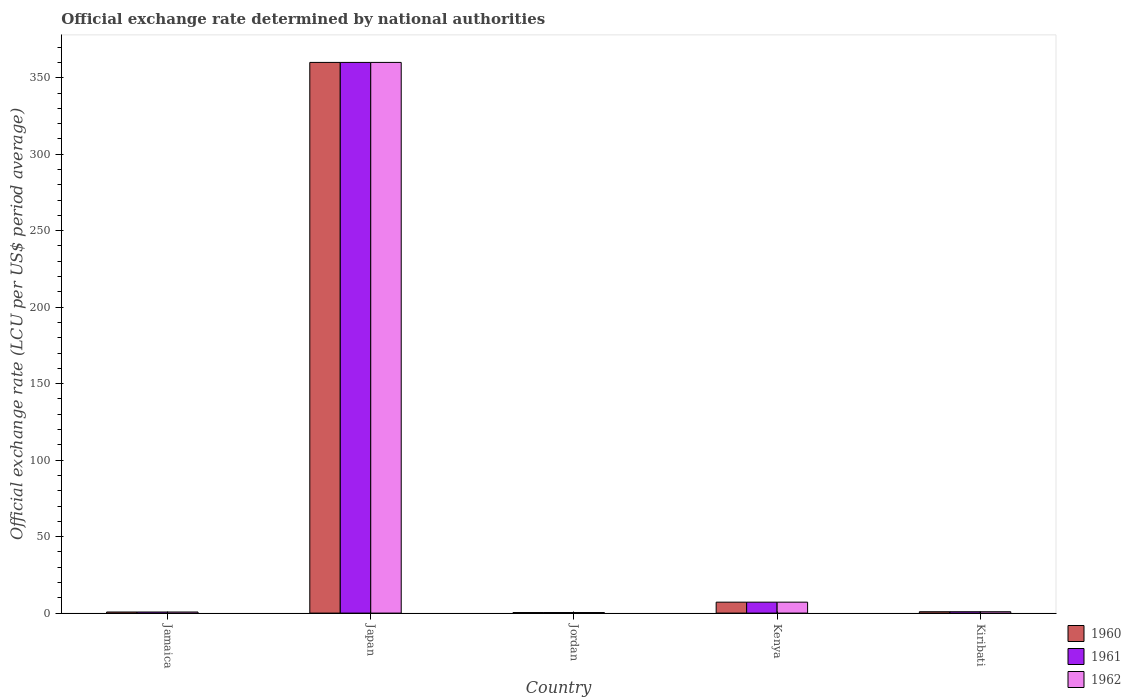How many different coloured bars are there?
Provide a succinct answer. 3. How many bars are there on the 4th tick from the left?
Your response must be concise. 3. How many bars are there on the 3rd tick from the right?
Keep it short and to the point. 3. What is the official exchange rate in 1961 in Jordan?
Ensure brevity in your answer.  0.36. Across all countries, what is the maximum official exchange rate in 1960?
Keep it short and to the point. 360. Across all countries, what is the minimum official exchange rate in 1962?
Your response must be concise. 0.36. In which country was the official exchange rate in 1960 minimum?
Your answer should be compact. Jordan. What is the total official exchange rate in 1960 in the graph?
Offer a terse response. 369.11. What is the difference between the official exchange rate in 1960 in Jordan and that in Kiribati?
Keep it short and to the point. -0.54. What is the difference between the official exchange rate in 1962 in Kenya and the official exchange rate in 1960 in Kiribati?
Offer a very short reply. 6.25. What is the average official exchange rate in 1962 per country?
Give a very brief answer. 73.82. What is the difference between the official exchange rate of/in 1960 and official exchange rate of/in 1961 in Kenya?
Keep it short and to the point. 0. In how many countries, is the official exchange rate in 1961 greater than 120 LCU?
Keep it short and to the point. 1. What is the ratio of the official exchange rate in 1962 in Japan to that in Kenya?
Give a very brief answer. 50.4. Is the official exchange rate in 1960 in Jamaica less than that in Jordan?
Ensure brevity in your answer.  No. Is the difference between the official exchange rate in 1960 in Jordan and Kenya greater than the difference between the official exchange rate in 1961 in Jordan and Kenya?
Give a very brief answer. No. What is the difference between the highest and the second highest official exchange rate in 1961?
Provide a short and direct response. 359.11. What is the difference between the highest and the lowest official exchange rate in 1962?
Make the answer very short. 359.64. Is the sum of the official exchange rate in 1961 in Kenya and Kiribati greater than the maximum official exchange rate in 1960 across all countries?
Offer a very short reply. No. What does the 1st bar from the right in Kiribati represents?
Offer a terse response. 1962. Are all the bars in the graph horizontal?
Offer a terse response. No. What is the difference between two consecutive major ticks on the Y-axis?
Give a very brief answer. 50. Are the values on the major ticks of Y-axis written in scientific E-notation?
Your answer should be very brief. No. Does the graph contain any zero values?
Offer a very short reply. No. Does the graph contain grids?
Your response must be concise. No. Where does the legend appear in the graph?
Provide a succinct answer. Bottom right. How many legend labels are there?
Give a very brief answer. 3. How are the legend labels stacked?
Offer a terse response. Vertical. What is the title of the graph?
Give a very brief answer. Official exchange rate determined by national authorities. What is the label or title of the X-axis?
Your answer should be very brief. Country. What is the label or title of the Y-axis?
Give a very brief answer. Official exchange rate (LCU per US$ period average). What is the Official exchange rate (LCU per US$ period average) in 1960 in Jamaica?
Your answer should be compact. 0.71. What is the Official exchange rate (LCU per US$ period average) of 1961 in Jamaica?
Provide a short and direct response. 0.71. What is the Official exchange rate (LCU per US$ period average) in 1962 in Jamaica?
Provide a short and direct response. 0.71. What is the Official exchange rate (LCU per US$ period average) of 1960 in Japan?
Your response must be concise. 360. What is the Official exchange rate (LCU per US$ period average) in 1961 in Japan?
Provide a short and direct response. 360. What is the Official exchange rate (LCU per US$ period average) in 1962 in Japan?
Your response must be concise. 360. What is the Official exchange rate (LCU per US$ period average) in 1960 in Jordan?
Give a very brief answer. 0.36. What is the Official exchange rate (LCU per US$ period average) of 1961 in Jordan?
Ensure brevity in your answer.  0.36. What is the Official exchange rate (LCU per US$ period average) in 1962 in Jordan?
Offer a terse response. 0.36. What is the Official exchange rate (LCU per US$ period average) in 1960 in Kenya?
Provide a short and direct response. 7.14. What is the Official exchange rate (LCU per US$ period average) of 1961 in Kenya?
Ensure brevity in your answer.  7.14. What is the Official exchange rate (LCU per US$ period average) in 1962 in Kenya?
Ensure brevity in your answer.  7.14. What is the Official exchange rate (LCU per US$ period average) of 1960 in Kiribati?
Offer a very short reply. 0.89. What is the Official exchange rate (LCU per US$ period average) in 1961 in Kiribati?
Provide a short and direct response. 0.89. What is the Official exchange rate (LCU per US$ period average) in 1962 in Kiribati?
Make the answer very short. 0.89. Across all countries, what is the maximum Official exchange rate (LCU per US$ period average) of 1960?
Provide a short and direct response. 360. Across all countries, what is the maximum Official exchange rate (LCU per US$ period average) of 1961?
Give a very brief answer. 360. Across all countries, what is the maximum Official exchange rate (LCU per US$ period average) in 1962?
Provide a succinct answer. 360. Across all countries, what is the minimum Official exchange rate (LCU per US$ period average) in 1960?
Offer a terse response. 0.36. Across all countries, what is the minimum Official exchange rate (LCU per US$ period average) in 1961?
Make the answer very short. 0.36. Across all countries, what is the minimum Official exchange rate (LCU per US$ period average) in 1962?
Provide a succinct answer. 0.36. What is the total Official exchange rate (LCU per US$ period average) in 1960 in the graph?
Keep it short and to the point. 369.11. What is the total Official exchange rate (LCU per US$ period average) in 1961 in the graph?
Provide a short and direct response. 369.11. What is the total Official exchange rate (LCU per US$ period average) of 1962 in the graph?
Offer a very short reply. 369.11. What is the difference between the Official exchange rate (LCU per US$ period average) in 1960 in Jamaica and that in Japan?
Keep it short and to the point. -359.29. What is the difference between the Official exchange rate (LCU per US$ period average) of 1961 in Jamaica and that in Japan?
Offer a very short reply. -359.29. What is the difference between the Official exchange rate (LCU per US$ period average) in 1962 in Jamaica and that in Japan?
Give a very brief answer. -359.29. What is the difference between the Official exchange rate (LCU per US$ period average) of 1960 in Jamaica and that in Jordan?
Your answer should be very brief. 0.36. What is the difference between the Official exchange rate (LCU per US$ period average) in 1961 in Jamaica and that in Jordan?
Offer a very short reply. 0.36. What is the difference between the Official exchange rate (LCU per US$ period average) of 1962 in Jamaica and that in Jordan?
Offer a very short reply. 0.36. What is the difference between the Official exchange rate (LCU per US$ period average) in 1960 in Jamaica and that in Kenya?
Offer a terse response. -6.43. What is the difference between the Official exchange rate (LCU per US$ period average) of 1961 in Jamaica and that in Kenya?
Your answer should be compact. -6.43. What is the difference between the Official exchange rate (LCU per US$ period average) in 1962 in Jamaica and that in Kenya?
Provide a succinct answer. -6.43. What is the difference between the Official exchange rate (LCU per US$ period average) of 1960 in Jamaica and that in Kiribati?
Keep it short and to the point. -0.18. What is the difference between the Official exchange rate (LCU per US$ period average) of 1961 in Jamaica and that in Kiribati?
Give a very brief answer. -0.18. What is the difference between the Official exchange rate (LCU per US$ period average) in 1962 in Jamaica and that in Kiribati?
Offer a very short reply. -0.18. What is the difference between the Official exchange rate (LCU per US$ period average) of 1960 in Japan and that in Jordan?
Give a very brief answer. 359.64. What is the difference between the Official exchange rate (LCU per US$ period average) in 1961 in Japan and that in Jordan?
Offer a terse response. 359.64. What is the difference between the Official exchange rate (LCU per US$ period average) in 1962 in Japan and that in Jordan?
Give a very brief answer. 359.64. What is the difference between the Official exchange rate (LCU per US$ period average) in 1960 in Japan and that in Kenya?
Provide a short and direct response. 352.86. What is the difference between the Official exchange rate (LCU per US$ period average) of 1961 in Japan and that in Kenya?
Ensure brevity in your answer.  352.86. What is the difference between the Official exchange rate (LCU per US$ period average) in 1962 in Japan and that in Kenya?
Your answer should be very brief. 352.86. What is the difference between the Official exchange rate (LCU per US$ period average) of 1960 in Japan and that in Kiribati?
Offer a very short reply. 359.11. What is the difference between the Official exchange rate (LCU per US$ period average) of 1961 in Japan and that in Kiribati?
Offer a terse response. 359.11. What is the difference between the Official exchange rate (LCU per US$ period average) of 1962 in Japan and that in Kiribati?
Provide a succinct answer. 359.11. What is the difference between the Official exchange rate (LCU per US$ period average) of 1960 in Jordan and that in Kenya?
Provide a short and direct response. -6.79. What is the difference between the Official exchange rate (LCU per US$ period average) of 1961 in Jordan and that in Kenya?
Your answer should be compact. -6.79. What is the difference between the Official exchange rate (LCU per US$ period average) in 1962 in Jordan and that in Kenya?
Offer a very short reply. -6.79. What is the difference between the Official exchange rate (LCU per US$ period average) of 1960 in Jordan and that in Kiribati?
Your answer should be compact. -0.54. What is the difference between the Official exchange rate (LCU per US$ period average) in 1961 in Jordan and that in Kiribati?
Ensure brevity in your answer.  -0.54. What is the difference between the Official exchange rate (LCU per US$ period average) in 1962 in Jordan and that in Kiribati?
Provide a short and direct response. -0.54. What is the difference between the Official exchange rate (LCU per US$ period average) of 1960 in Kenya and that in Kiribati?
Provide a short and direct response. 6.25. What is the difference between the Official exchange rate (LCU per US$ period average) of 1961 in Kenya and that in Kiribati?
Offer a very short reply. 6.25. What is the difference between the Official exchange rate (LCU per US$ period average) of 1962 in Kenya and that in Kiribati?
Make the answer very short. 6.25. What is the difference between the Official exchange rate (LCU per US$ period average) of 1960 in Jamaica and the Official exchange rate (LCU per US$ period average) of 1961 in Japan?
Make the answer very short. -359.29. What is the difference between the Official exchange rate (LCU per US$ period average) of 1960 in Jamaica and the Official exchange rate (LCU per US$ period average) of 1962 in Japan?
Your answer should be very brief. -359.29. What is the difference between the Official exchange rate (LCU per US$ period average) of 1961 in Jamaica and the Official exchange rate (LCU per US$ period average) of 1962 in Japan?
Ensure brevity in your answer.  -359.29. What is the difference between the Official exchange rate (LCU per US$ period average) in 1960 in Jamaica and the Official exchange rate (LCU per US$ period average) in 1961 in Jordan?
Offer a terse response. 0.36. What is the difference between the Official exchange rate (LCU per US$ period average) in 1960 in Jamaica and the Official exchange rate (LCU per US$ period average) in 1962 in Jordan?
Make the answer very short. 0.36. What is the difference between the Official exchange rate (LCU per US$ period average) of 1961 in Jamaica and the Official exchange rate (LCU per US$ period average) of 1962 in Jordan?
Your response must be concise. 0.36. What is the difference between the Official exchange rate (LCU per US$ period average) of 1960 in Jamaica and the Official exchange rate (LCU per US$ period average) of 1961 in Kenya?
Provide a succinct answer. -6.43. What is the difference between the Official exchange rate (LCU per US$ period average) in 1960 in Jamaica and the Official exchange rate (LCU per US$ period average) in 1962 in Kenya?
Provide a succinct answer. -6.43. What is the difference between the Official exchange rate (LCU per US$ period average) of 1961 in Jamaica and the Official exchange rate (LCU per US$ period average) of 1962 in Kenya?
Offer a terse response. -6.43. What is the difference between the Official exchange rate (LCU per US$ period average) in 1960 in Jamaica and the Official exchange rate (LCU per US$ period average) in 1961 in Kiribati?
Make the answer very short. -0.18. What is the difference between the Official exchange rate (LCU per US$ period average) of 1960 in Jamaica and the Official exchange rate (LCU per US$ period average) of 1962 in Kiribati?
Your answer should be very brief. -0.18. What is the difference between the Official exchange rate (LCU per US$ period average) in 1961 in Jamaica and the Official exchange rate (LCU per US$ period average) in 1962 in Kiribati?
Provide a short and direct response. -0.18. What is the difference between the Official exchange rate (LCU per US$ period average) in 1960 in Japan and the Official exchange rate (LCU per US$ period average) in 1961 in Jordan?
Keep it short and to the point. 359.64. What is the difference between the Official exchange rate (LCU per US$ period average) of 1960 in Japan and the Official exchange rate (LCU per US$ period average) of 1962 in Jordan?
Your answer should be compact. 359.64. What is the difference between the Official exchange rate (LCU per US$ period average) of 1961 in Japan and the Official exchange rate (LCU per US$ period average) of 1962 in Jordan?
Provide a short and direct response. 359.64. What is the difference between the Official exchange rate (LCU per US$ period average) in 1960 in Japan and the Official exchange rate (LCU per US$ period average) in 1961 in Kenya?
Your answer should be compact. 352.86. What is the difference between the Official exchange rate (LCU per US$ period average) in 1960 in Japan and the Official exchange rate (LCU per US$ period average) in 1962 in Kenya?
Give a very brief answer. 352.86. What is the difference between the Official exchange rate (LCU per US$ period average) of 1961 in Japan and the Official exchange rate (LCU per US$ period average) of 1962 in Kenya?
Your answer should be compact. 352.86. What is the difference between the Official exchange rate (LCU per US$ period average) of 1960 in Japan and the Official exchange rate (LCU per US$ period average) of 1961 in Kiribati?
Offer a very short reply. 359.11. What is the difference between the Official exchange rate (LCU per US$ period average) in 1960 in Japan and the Official exchange rate (LCU per US$ period average) in 1962 in Kiribati?
Your response must be concise. 359.11. What is the difference between the Official exchange rate (LCU per US$ period average) of 1961 in Japan and the Official exchange rate (LCU per US$ period average) of 1962 in Kiribati?
Offer a very short reply. 359.11. What is the difference between the Official exchange rate (LCU per US$ period average) of 1960 in Jordan and the Official exchange rate (LCU per US$ period average) of 1961 in Kenya?
Keep it short and to the point. -6.79. What is the difference between the Official exchange rate (LCU per US$ period average) of 1960 in Jordan and the Official exchange rate (LCU per US$ period average) of 1962 in Kenya?
Offer a terse response. -6.79. What is the difference between the Official exchange rate (LCU per US$ period average) in 1961 in Jordan and the Official exchange rate (LCU per US$ period average) in 1962 in Kenya?
Provide a short and direct response. -6.79. What is the difference between the Official exchange rate (LCU per US$ period average) of 1960 in Jordan and the Official exchange rate (LCU per US$ period average) of 1961 in Kiribati?
Your answer should be compact. -0.54. What is the difference between the Official exchange rate (LCU per US$ period average) of 1960 in Jordan and the Official exchange rate (LCU per US$ period average) of 1962 in Kiribati?
Ensure brevity in your answer.  -0.54. What is the difference between the Official exchange rate (LCU per US$ period average) in 1961 in Jordan and the Official exchange rate (LCU per US$ period average) in 1962 in Kiribati?
Make the answer very short. -0.54. What is the difference between the Official exchange rate (LCU per US$ period average) of 1960 in Kenya and the Official exchange rate (LCU per US$ period average) of 1961 in Kiribati?
Ensure brevity in your answer.  6.25. What is the difference between the Official exchange rate (LCU per US$ period average) of 1960 in Kenya and the Official exchange rate (LCU per US$ period average) of 1962 in Kiribati?
Your answer should be very brief. 6.25. What is the difference between the Official exchange rate (LCU per US$ period average) in 1961 in Kenya and the Official exchange rate (LCU per US$ period average) in 1962 in Kiribati?
Your response must be concise. 6.25. What is the average Official exchange rate (LCU per US$ period average) of 1960 per country?
Offer a terse response. 73.82. What is the average Official exchange rate (LCU per US$ period average) of 1961 per country?
Give a very brief answer. 73.82. What is the average Official exchange rate (LCU per US$ period average) of 1962 per country?
Provide a succinct answer. 73.82. What is the difference between the Official exchange rate (LCU per US$ period average) of 1960 and Official exchange rate (LCU per US$ period average) of 1961 in Jamaica?
Your answer should be compact. 0. What is the difference between the Official exchange rate (LCU per US$ period average) in 1960 and Official exchange rate (LCU per US$ period average) in 1962 in Jamaica?
Your response must be concise. 0. What is the difference between the Official exchange rate (LCU per US$ period average) in 1961 and Official exchange rate (LCU per US$ period average) in 1962 in Jamaica?
Keep it short and to the point. 0. What is the difference between the Official exchange rate (LCU per US$ period average) of 1961 and Official exchange rate (LCU per US$ period average) of 1962 in Japan?
Provide a short and direct response. 0. What is the difference between the Official exchange rate (LCU per US$ period average) of 1961 and Official exchange rate (LCU per US$ period average) of 1962 in Jordan?
Your answer should be compact. 0. What is the difference between the Official exchange rate (LCU per US$ period average) in 1961 and Official exchange rate (LCU per US$ period average) in 1962 in Kenya?
Your answer should be very brief. 0. What is the ratio of the Official exchange rate (LCU per US$ period average) of 1960 in Jamaica to that in Japan?
Provide a succinct answer. 0. What is the ratio of the Official exchange rate (LCU per US$ period average) in 1961 in Jamaica to that in Japan?
Provide a succinct answer. 0. What is the ratio of the Official exchange rate (LCU per US$ period average) in 1962 in Jamaica to that in Japan?
Provide a short and direct response. 0. What is the ratio of the Official exchange rate (LCU per US$ period average) in 1961 in Jamaica to that in Jordan?
Offer a terse response. 2. What is the ratio of the Official exchange rate (LCU per US$ period average) of 1962 in Jamaica to that in Kenya?
Offer a terse response. 0.1. What is the ratio of the Official exchange rate (LCU per US$ period average) of 1960 in Jamaica to that in Kiribati?
Offer a terse response. 0.8. What is the ratio of the Official exchange rate (LCU per US$ period average) of 1962 in Jamaica to that in Kiribati?
Offer a very short reply. 0.8. What is the ratio of the Official exchange rate (LCU per US$ period average) in 1960 in Japan to that in Jordan?
Your answer should be very brief. 1008. What is the ratio of the Official exchange rate (LCU per US$ period average) in 1961 in Japan to that in Jordan?
Keep it short and to the point. 1008. What is the ratio of the Official exchange rate (LCU per US$ period average) in 1962 in Japan to that in Jordan?
Provide a short and direct response. 1008. What is the ratio of the Official exchange rate (LCU per US$ period average) in 1960 in Japan to that in Kenya?
Your answer should be very brief. 50.4. What is the ratio of the Official exchange rate (LCU per US$ period average) of 1961 in Japan to that in Kenya?
Your response must be concise. 50.4. What is the ratio of the Official exchange rate (LCU per US$ period average) in 1962 in Japan to that in Kenya?
Give a very brief answer. 50.4. What is the ratio of the Official exchange rate (LCU per US$ period average) of 1960 in Japan to that in Kiribati?
Your answer should be very brief. 403.2. What is the ratio of the Official exchange rate (LCU per US$ period average) of 1961 in Japan to that in Kiribati?
Your answer should be very brief. 403.2. What is the ratio of the Official exchange rate (LCU per US$ period average) in 1962 in Japan to that in Kiribati?
Your response must be concise. 403.2. What is the ratio of the Official exchange rate (LCU per US$ period average) in 1960 in Jordan to that in Kenya?
Offer a very short reply. 0.05. What is the ratio of the Official exchange rate (LCU per US$ period average) of 1960 in Jordan to that in Kiribati?
Offer a terse response. 0.4. What is the ratio of the Official exchange rate (LCU per US$ period average) in 1961 in Jordan to that in Kiribati?
Make the answer very short. 0.4. What is the ratio of the Official exchange rate (LCU per US$ period average) of 1962 in Jordan to that in Kiribati?
Provide a succinct answer. 0.4. What is the ratio of the Official exchange rate (LCU per US$ period average) of 1962 in Kenya to that in Kiribati?
Keep it short and to the point. 8. What is the difference between the highest and the second highest Official exchange rate (LCU per US$ period average) in 1960?
Make the answer very short. 352.86. What is the difference between the highest and the second highest Official exchange rate (LCU per US$ period average) in 1961?
Keep it short and to the point. 352.86. What is the difference between the highest and the second highest Official exchange rate (LCU per US$ period average) of 1962?
Provide a short and direct response. 352.86. What is the difference between the highest and the lowest Official exchange rate (LCU per US$ period average) in 1960?
Provide a short and direct response. 359.64. What is the difference between the highest and the lowest Official exchange rate (LCU per US$ period average) of 1961?
Provide a succinct answer. 359.64. What is the difference between the highest and the lowest Official exchange rate (LCU per US$ period average) of 1962?
Provide a short and direct response. 359.64. 